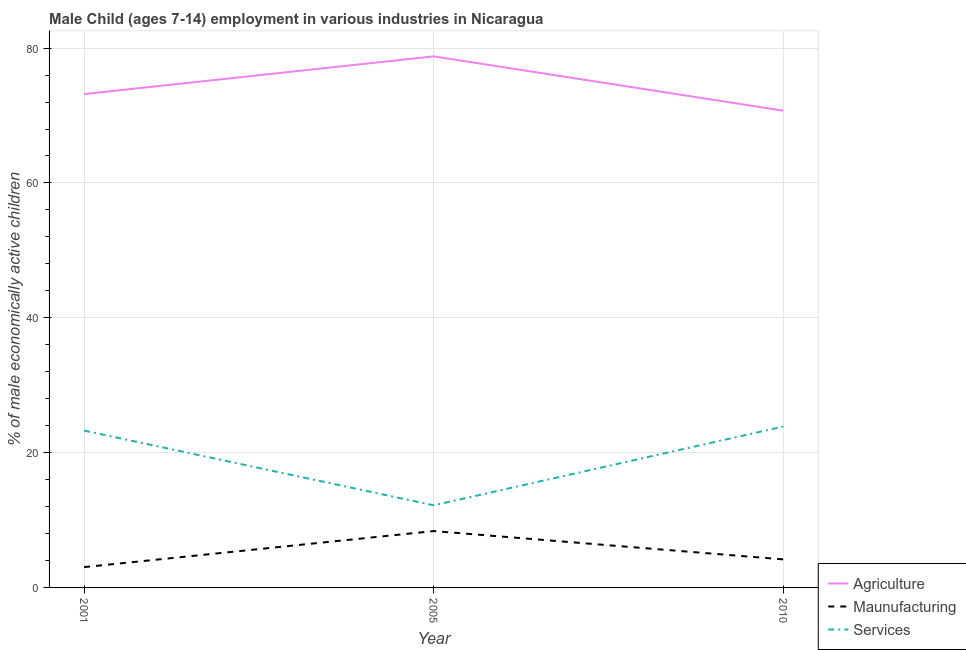How many different coloured lines are there?
Keep it short and to the point. 3. Does the line corresponding to percentage of economically active children in services intersect with the line corresponding to percentage of economically active children in manufacturing?
Give a very brief answer. No. Is the number of lines equal to the number of legend labels?
Make the answer very short. Yes. What is the percentage of economically active children in services in 2005?
Make the answer very short. 12.18. Across all years, what is the maximum percentage of economically active children in services?
Give a very brief answer. 23.87. Across all years, what is the minimum percentage of economically active children in agriculture?
Offer a terse response. 70.72. In which year was the percentage of economically active children in services maximum?
Offer a very short reply. 2010. What is the total percentage of economically active children in services in the graph?
Make the answer very short. 59.32. What is the difference between the percentage of economically active children in manufacturing in 2005 and that in 2010?
Provide a succinct answer. 4.2. What is the difference between the percentage of economically active children in manufacturing in 2010 and the percentage of economically active children in agriculture in 2001?
Ensure brevity in your answer.  -69.03. What is the average percentage of economically active children in services per year?
Offer a terse response. 19.77. In the year 2005, what is the difference between the percentage of economically active children in agriculture and percentage of economically active children in services?
Offer a very short reply. 66.6. What is the ratio of the percentage of economically active children in agriculture in 2005 to that in 2010?
Your answer should be compact. 1.11. Is the percentage of economically active children in agriculture in 2001 less than that in 2010?
Make the answer very short. No. What is the difference between the highest and the second highest percentage of economically active children in manufacturing?
Offer a very short reply. 4.2. What is the difference between the highest and the lowest percentage of economically active children in manufacturing?
Ensure brevity in your answer.  5.35. Is the sum of the percentage of economically active children in services in 2005 and 2010 greater than the maximum percentage of economically active children in manufacturing across all years?
Your answer should be very brief. Yes. Is the percentage of economically active children in agriculture strictly less than the percentage of economically active children in services over the years?
Your answer should be compact. No. How many lines are there?
Give a very brief answer. 3. What is the difference between two consecutive major ticks on the Y-axis?
Ensure brevity in your answer.  20. Are the values on the major ticks of Y-axis written in scientific E-notation?
Provide a short and direct response. No. Does the graph contain any zero values?
Give a very brief answer. No. Does the graph contain grids?
Offer a terse response. Yes. Where does the legend appear in the graph?
Your answer should be compact. Bottom right. How many legend labels are there?
Give a very brief answer. 3. What is the title of the graph?
Ensure brevity in your answer.  Male Child (ages 7-14) employment in various industries in Nicaragua. Does "Oil sources" appear as one of the legend labels in the graph?
Give a very brief answer. No. What is the label or title of the X-axis?
Your answer should be compact. Year. What is the label or title of the Y-axis?
Provide a short and direct response. % of male economically active children. What is the % of male economically active children in Agriculture in 2001?
Make the answer very short. 73.19. What is the % of male economically active children of Maunufacturing in 2001?
Provide a short and direct response. 3.01. What is the % of male economically active children in Services in 2001?
Provide a succinct answer. 23.27. What is the % of male economically active children in Agriculture in 2005?
Provide a short and direct response. 78.78. What is the % of male economically active children of Maunufacturing in 2005?
Offer a terse response. 8.36. What is the % of male economically active children in Services in 2005?
Provide a succinct answer. 12.18. What is the % of male economically active children of Agriculture in 2010?
Ensure brevity in your answer.  70.72. What is the % of male economically active children of Maunufacturing in 2010?
Your answer should be compact. 4.16. What is the % of male economically active children in Services in 2010?
Your response must be concise. 23.87. Across all years, what is the maximum % of male economically active children of Agriculture?
Offer a very short reply. 78.78. Across all years, what is the maximum % of male economically active children of Maunufacturing?
Your response must be concise. 8.36. Across all years, what is the maximum % of male economically active children of Services?
Offer a terse response. 23.87. Across all years, what is the minimum % of male economically active children in Agriculture?
Your response must be concise. 70.72. Across all years, what is the minimum % of male economically active children of Maunufacturing?
Give a very brief answer. 3.01. Across all years, what is the minimum % of male economically active children of Services?
Provide a short and direct response. 12.18. What is the total % of male economically active children in Agriculture in the graph?
Provide a short and direct response. 222.69. What is the total % of male economically active children of Maunufacturing in the graph?
Your answer should be very brief. 15.53. What is the total % of male economically active children of Services in the graph?
Your answer should be compact. 59.32. What is the difference between the % of male economically active children of Agriculture in 2001 and that in 2005?
Provide a succinct answer. -5.59. What is the difference between the % of male economically active children in Maunufacturing in 2001 and that in 2005?
Your answer should be very brief. -5.35. What is the difference between the % of male economically active children in Services in 2001 and that in 2005?
Offer a terse response. 11.09. What is the difference between the % of male economically active children in Agriculture in 2001 and that in 2010?
Your answer should be very brief. 2.47. What is the difference between the % of male economically active children of Maunufacturing in 2001 and that in 2010?
Give a very brief answer. -1.15. What is the difference between the % of male economically active children in Services in 2001 and that in 2010?
Provide a short and direct response. -0.6. What is the difference between the % of male economically active children in Agriculture in 2005 and that in 2010?
Your answer should be very brief. 8.06. What is the difference between the % of male economically active children in Services in 2005 and that in 2010?
Give a very brief answer. -11.69. What is the difference between the % of male economically active children in Agriculture in 2001 and the % of male economically active children in Maunufacturing in 2005?
Offer a terse response. 64.83. What is the difference between the % of male economically active children in Agriculture in 2001 and the % of male economically active children in Services in 2005?
Offer a very short reply. 61.01. What is the difference between the % of male economically active children in Maunufacturing in 2001 and the % of male economically active children in Services in 2005?
Keep it short and to the point. -9.17. What is the difference between the % of male economically active children in Agriculture in 2001 and the % of male economically active children in Maunufacturing in 2010?
Offer a terse response. 69.03. What is the difference between the % of male economically active children of Agriculture in 2001 and the % of male economically active children of Services in 2010?
Keep it short and to the point. 49.32. What is the difference between the % of male economically active children of Maunufacturing in 2001 and the % of male economically active children of Services in 2010?
Make the answer very short. -20.86. What is the difference between the % of male economically active children of Agriculture in 2005 and the % of male economically active children of Maunufacturing in 2010?
Your answer should be compact. 74.62. What is the difference between the % of male economically active children of Agriculture in 2005 and the % of male economically active children of Services in 2010?
Your response must be concise. 54.91. What is the difference between the % of male economically active children of Maunufacturing in 2005 and the % of male economically active children of Services in 2010?
Provide a succinct answer. -15.51. What is the average % of male economically active children in Agriculture per year?
Your answer should be very brief. 74.23. What is the average % of male economically active children of Maunufacturing per year?
Provide a short and direct response. 5.18. What is the average % of male economically active children of Services per year?
Keep it short and to the point. 19.77. In the year 2001, what is the difference between the % of male economically active children in Agriculture and % of male economically active children in Maunufacturing?
Provide a succinct answer. 70.17. In the year 2001, what is the difference between the % of male economically active children of Agriculture and % of male economically active children of Services?
Keep it short and to the point. 49.92. In the year 2001, what is the difference between the % of male economically active children in Maunufacturing and % of male economically active children in Services?
Offer a very short reply. -20.25. In the year 2005, what is the difference between the % of male economically active children in Agriculture and % of male economically active children in Maunufacturing?
Offer a very short reply. 70.42. In the year 2005, what is the difference between the % of male economically active children of Agriculture and % of male economically active children of Services?
Ensure brevity in your answer.  66.6. In the year 2005, what is the difference between the % of male economically active children of Maunufacturing and % of male economically active children of Services?
Give a very brief answer. -3.82. In the year 2010, what is the difference between the % of male economically active children of Agriculture and % of male economically active children of Maunufacturing?
Offer a very short reply. 66.56. In the year 2010, what is the difference between the % of male economically active children in Agriculture and % of male economically active children in Services?
Offer a terse response. 46.85. In the year 2010, what is the difference between the % of male economically active children in Maunufacturing and % of male economically active children in Services?
Your response must be concise. -19.71. What is the ratio of the % of male economically active children of Agriculture in 2001 to that in 2005?
Offer a very short reply. 0.93. What is the ratio of the % of male economically active children of Maunufacturing in 2001 to that in 2005?
Your answer should be compact. 0.36. What is the ratio of the % of male economically active children in Services in 2001 to that in 2005?
Your answer should be very brief. 1.91. What is the ratio of the % of male economically active children of Agriculture in 2001 to that in 2010?
Offer a terse response. 1.03. What is the ratio of the % of male economically active children of Maunufacturing in 2001 to that in 2010?
Keep it short and to the point. 0.72. What is the ratio of the % of male economically active children in Services in 2001 to that in 2010?
Ensure brevity in your answer.  0.97. What is the ratio of the % of male economically active children of Agriculture in 2005 to that in 2010?
Ensure brevity in your answer.  1.11. What is the ratio of the % of male economically active children of Maunufacturing in 2005 to that in 2010?
Your answer should be compact. 2.01. What is the ratio of the % of male economically active children in Services in 2005 to that in 2010?
Ensure brevity in your answer.  0.51. What is the difference between the highest and the second highest % of male economically active children of Agriculture?
Provide a succinct answer. 5.59. What is the difference between the highest and the second highest % of male economically active children in Maunufacturing?
Offer a terse response. 4.2. What is the difference between the highest and the second highest % of male economically active children in Services?
Keep it short and to the point. 0.6. What is the difference between the highest and the lowest % of male economically active children in Agriculture?
Keep it short and to the point. 8.06. What is the difference between the highest and the lowest % of male economically active children in Maunufacturing?
Keep it short and to the point. 5.35. What is the difference between the highest and the lowest % of male economically active children of Services?
Ensure brevity in your answer.  11.69. 